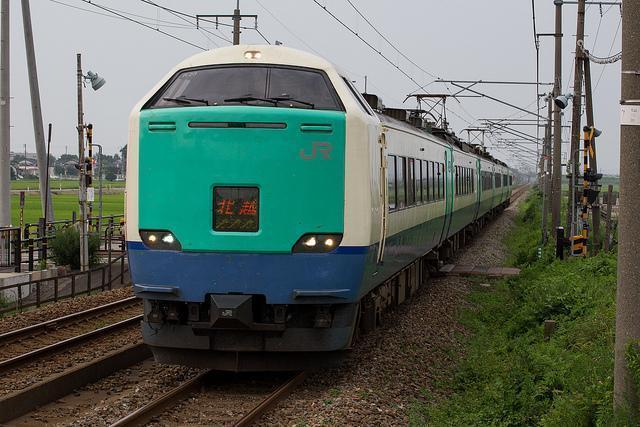How many headlights are on?
Give a very brief answer. 4. How many boys are wearing striped shirts?
Give a very brief answer. 0. 